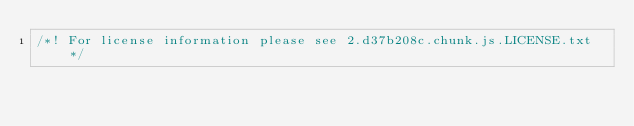<code> <loc_0><loc_0><loc_500><loc_500><_JavaScript_>/*! For license information please see 2.d37b208c.chunk.js.LICENSE.txt */</code> 